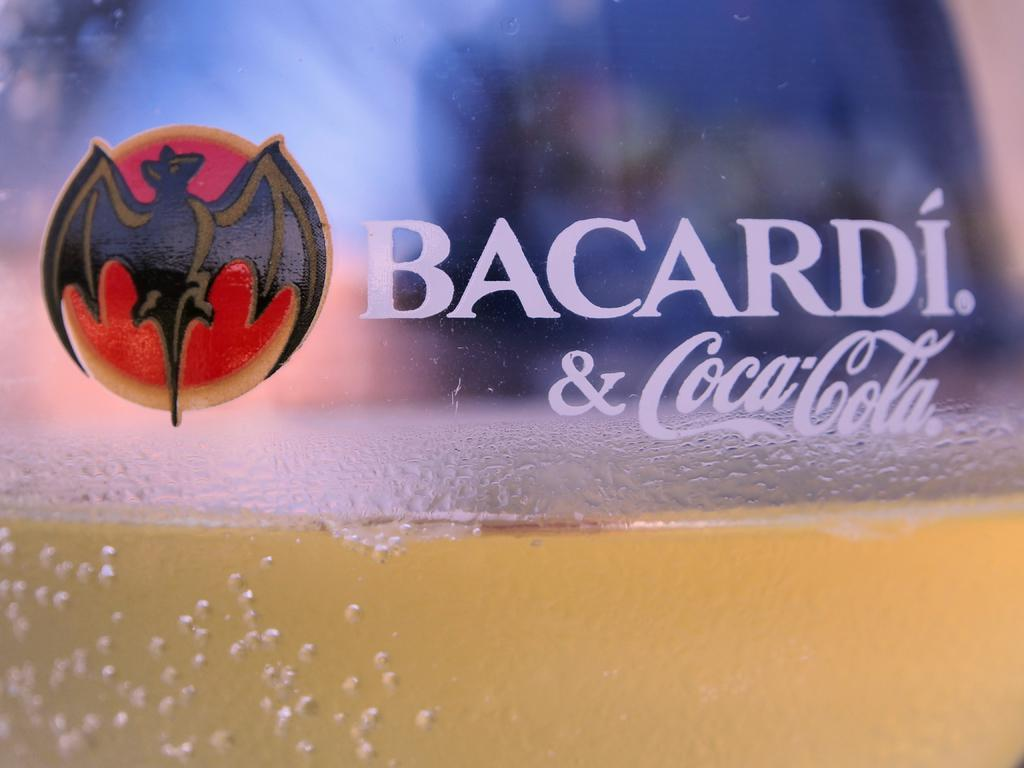<image>
Create a compact narrative representing the image presented. a glass bottle that has a label that says 'bacardi & coca-cola' on it 